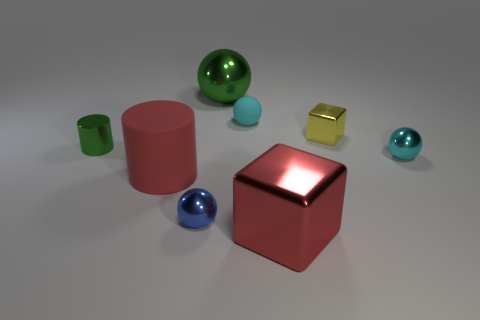What material is the cylinder that is the same size as the red block?
Give a very brief answer. Rubber. How many cyan objects are in front of the yellow thing?
Offer a terse response. 1. There is a red object that is right of the blue shiny object; is its shape the same as the small yellow metallic thing?
Keep it short and to the point. Yes. Is there a cyan shiny thing that has the same shape as the small matte object?
Offer a very short reply. Yes. What is the material of the cube that is the same color as the big matte thing?
Your answer should be compact. Metal. There is a rubber object on the right side of the red object behind the red metallic object; what is its shape?
Ensure brevity in your answer.  Sphere. How many tiny blocks are the same material as the tiny green cylinder?
Your answer should be very brief. 1. The tiny block that is made of the same material as the green sphere is what color?
Provide a short and direct response. Yellow. There is a metal sphere in front of the tiny ball that is on the right side of the large red thing on the right side of the large green metal thing; what size is it?
Ensure brevity in your answer.  Small. Is the number of big red shiny objects less than the number of big yellow matte spheres?
Make the answer very short. No. 